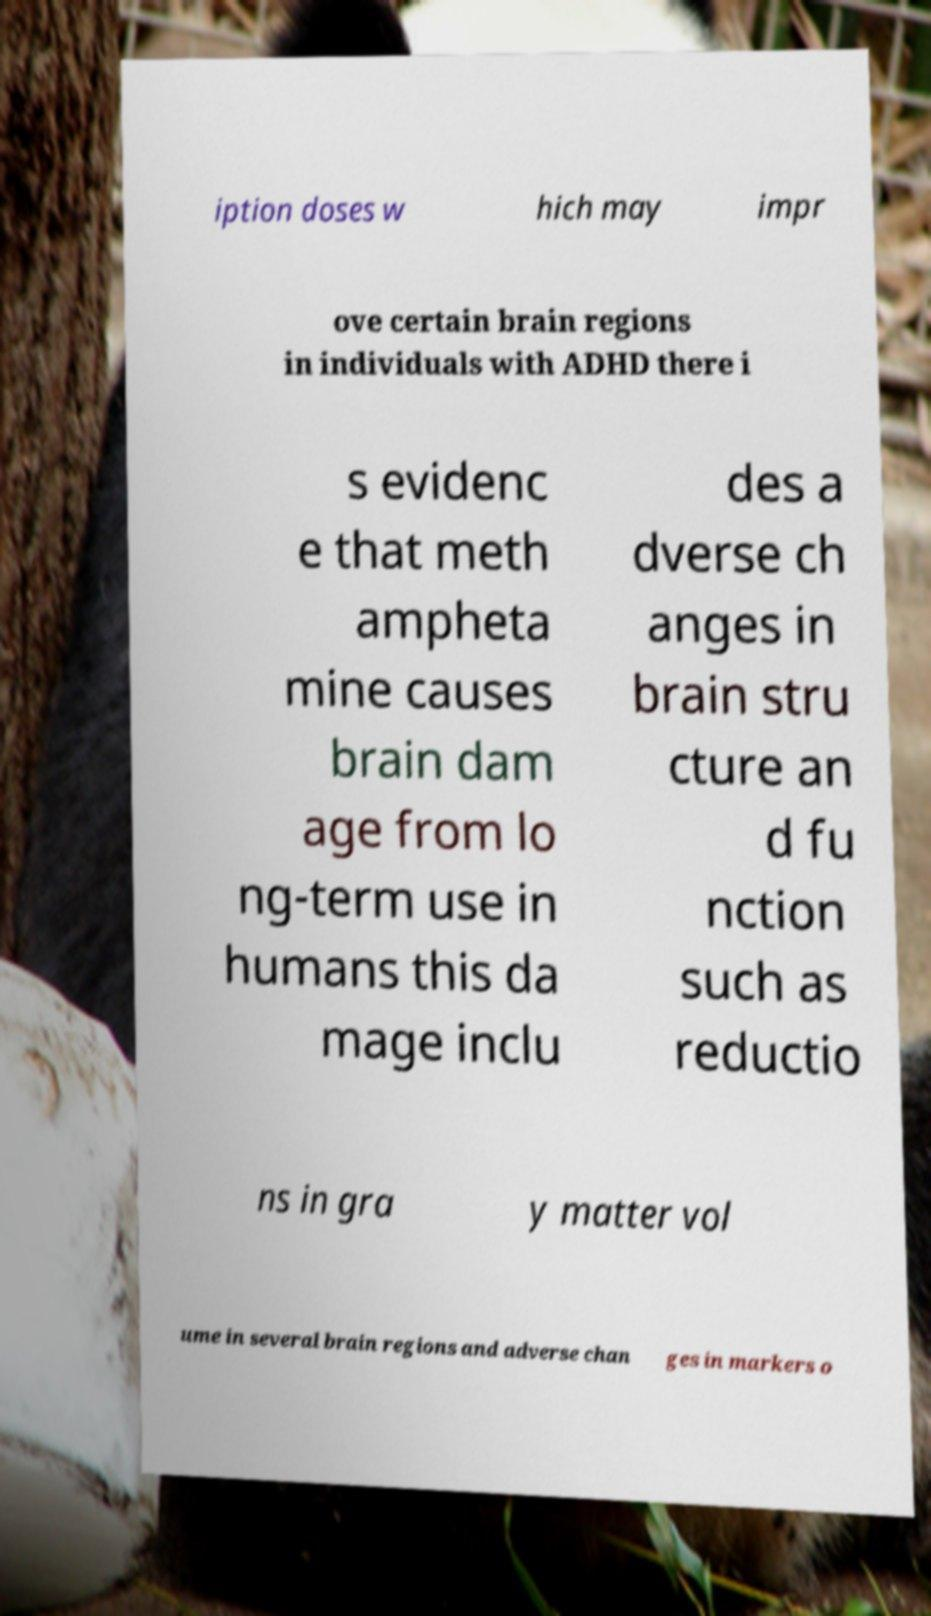What messages or text are displayed in this image? I need them in a readable, typed format. iption doses w hich may impr ove certain brain regions in individuals with ADHD there i s evidenc e that meth ampheta mine causes brain dam age from lo ng-term use in humans this da mage inclu des a dverse ch anges in brain stru cture an d fu nction such as reductio ns in gra y matter vol ume in several brain regions and adverse chan ges in markers o 